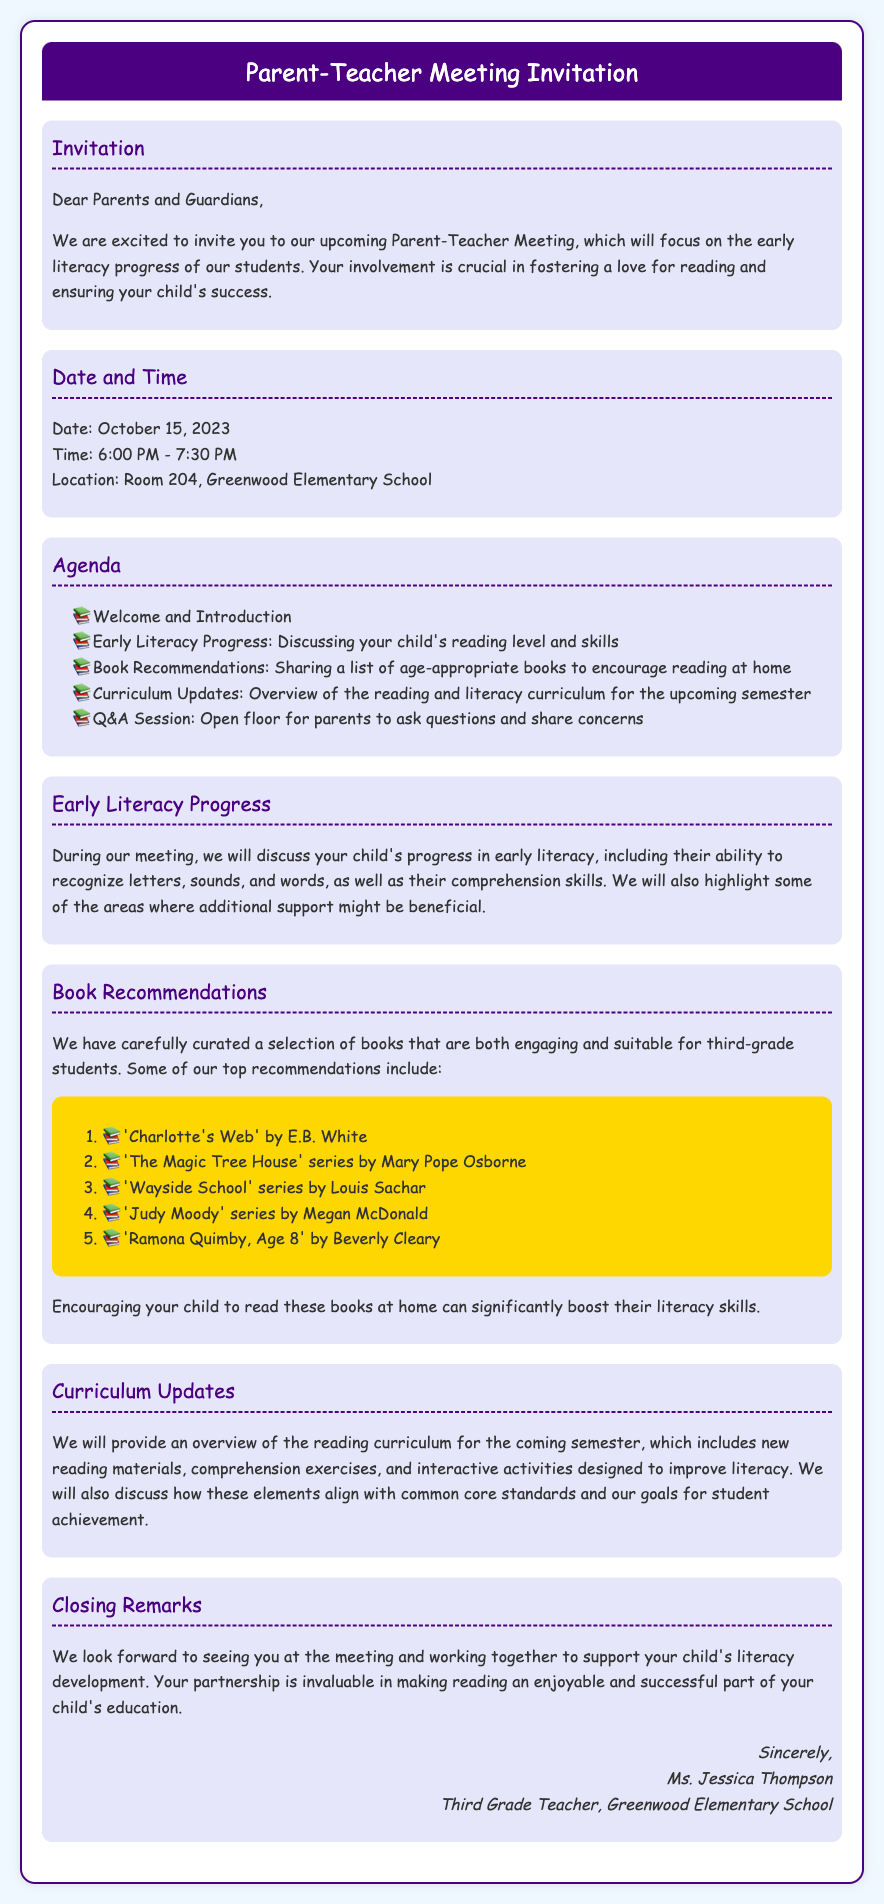What is the date of the Parent-Teacher Meeting? The date is specified in the document under "Date and Time."
Answer: October 15, 2023 What is the main focus of the Parent-Teacher Meeting? The focus is stated in the "Invitation" section of the document.
Answer: Early literacy progress What time does the meeting start? The start time is mentioned in the "Date and Time" section.
Answer: 6:00 PM Who is the teacher conducting the meeting? The teacher's name is listed in the closing remarks of the document.
Answer: Ms. Jessica Thompson What type of session will follow the discussions during the meeting? The type of session is described in the "Agenda" section of the document.
Answer: Q&A Session Which book is recommended first for encouraging reading? The first recommendation is found in the "Book Recommendations" section.
Answer: 'Charlotte's Web' by E.B. White What will be provided regarding the curriculum? This information can be found in the "Curriculum Updates" section of the document.
Answer: Overview of the reading curriculum What is one area discussed regarding early literacy? The areas to discuss are detailed in the "Early Literacy Progress" section.
Answer: Recognize letters, sounds, and words How will parents be invited to participate in the meeting? The method for parent participation is indicated in the "Invitation" section.
Answer: Your involvement is crucial 